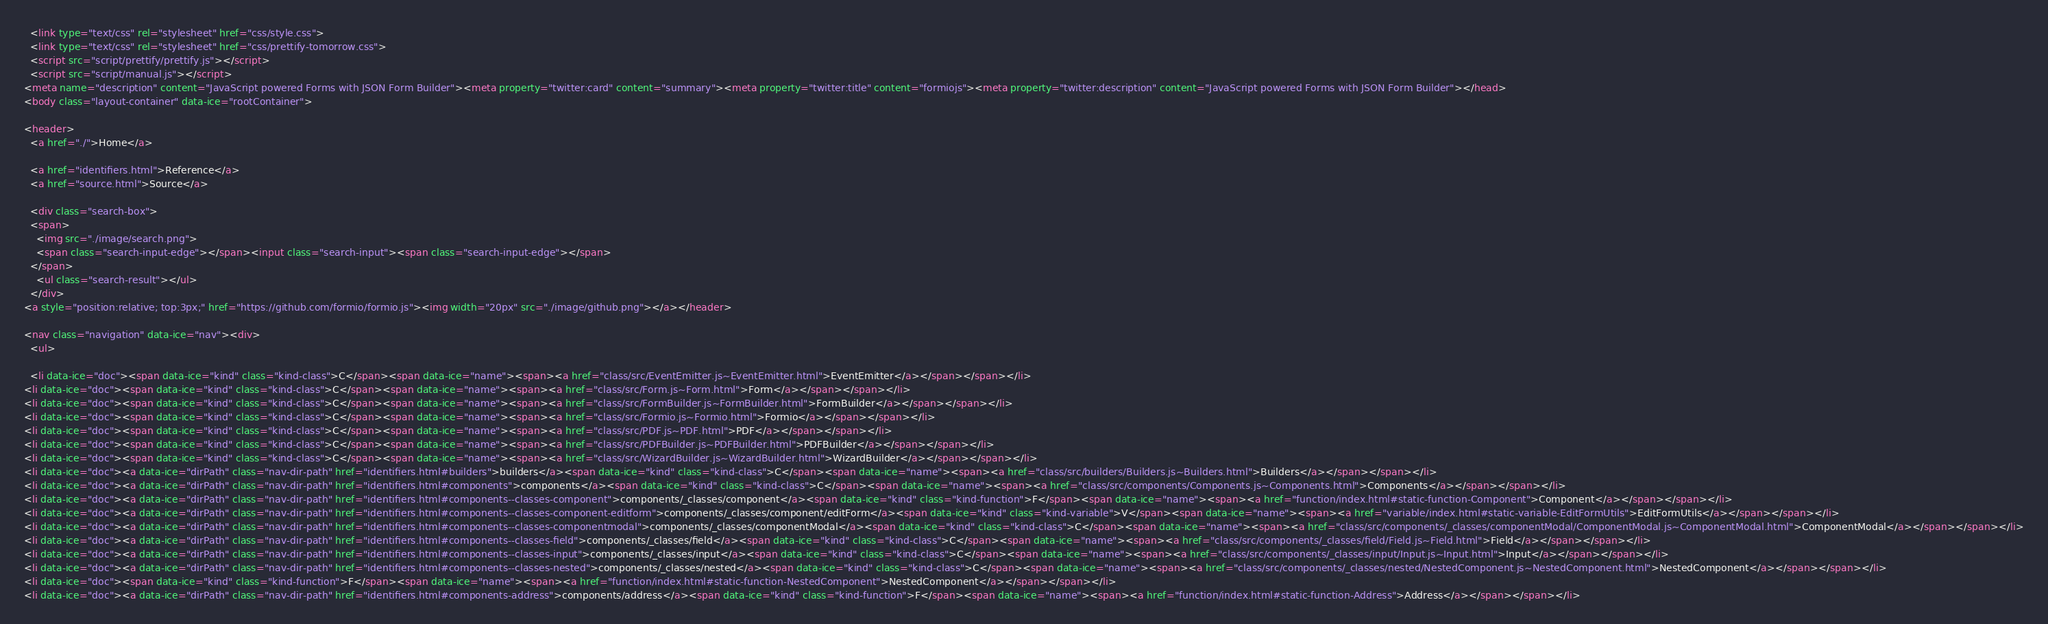<code> <loc_0><loc_0><loc_500><loc_500><_HTML_>  <link type="text/css" rel="stylesheet" href="css/style.css">
  <link type="text/css" rel="stylesheet" href="css/prettify-tomorrow.css">
  <script src="script/prettify/prettify.js"></script>
  <script src="script/manual.js"></script>
<meta name="description" content="JavaScript powered Forms with JSON Form Builder"><meta property="twitter:card" content="summary"><meta property="twitter:title" content="formiojs"><meta property="twitter:description" content="JavaScript powered Forms with JSON Form Builder"></head>
<body class="layout-container" data-ice="rootContainer">

<header>
  <a href="./">Home</a>
  
  <a href="identifiers.html">Reference</a>
  <a href="source.html">Source</a>
  
  <div class="search-box">
  <span>
    <img src="./image/search.png">
    <span class="search-input-edge"></span><input class="search-input"><span class="search-input-edge"></span>
  </span>
    <ul class="search-result"></ul>
  </div>
<a style="position:relative; top:3px;" href="https://github.com/formio/formio.js"><img width="20px" src="./image/github.png"></a></header>

<nav class="navigation" data-ice="nav"><div>
  <ul>
    
  <li data-ice="doc"><span data-ice="kind" class="kind-class">C</span><span data-ice="name"><span><a href="class/src/EventEmitter.js~EventEmitter.html">EventEmitter</a></span></span></li>
<li data-ice="doc"><span data-ice="kind" class="kind-class">C</span><span data-ice="name"><span><a href="class/src/Form.js~Form.html">Form</a></span></span></li>
<li data-ice="doc"><span data-ice="kind" class="kind-class">C</span><span data-ice="name"><span><a href="class/src/FormBuilder.js~FormBuilder.html">FormBuilder</a></span></span></li>
<li data-ice="doc"><span data-ice="kind" class="kind-class">C</span><span data-ice="name"><span><a href="class/src/Formio.js~Formio.html">Formio</a></span></span></li>
<li data-ice="doc"><span data-ice="kind" class="kind-class">C</span><span data-ice="name"><span><a href="class/src/PDF.js~PDF.html">PDF</a></span></span></li>
<li data-ice="doc"><span data-ice="kind" class="kind-class">C</span><span data-ice="name"><span><a href="class/src/PDFBuilder.js~PDFBuilder.html">PDFBuilder</a></span></span></li>
<li data-ice="doc"><span data-ice="kind" class="kind-class">C</span><span data-ice="name"><span><a href="class/src/WizardBuilder.js~WizardBuilder.html">WizardBuilder</a></span></span></li>
<li data-ice="doc"><a data-ice="dirPath" class="nav-dir-path" href="identifiers.html#builders">builders</a><span data-ice="kind" class="kind-class">C</span><span data-ice="name"><span><a href="class/src/builders/Builders.js~Builders.html">Builders</a></span></span></li>
<li data-ice="doc"><a data-ice="dirPath" class="nav-dir-path" href="identifiers.html#components">components</a><span data-ice="kind" class="kind-class">C</span><span data-ice="name"><span><a href="class/src/components/Components.js~Components.html">Components</a></span></span></li>
<li data-ice="doc"><a data-ice="dirPath" class="nav-dir-path" href="identifiers.html#components--classes-component">components/_classes/component</a><span data-ice="kind" class="kind-function">F</span><span data-ice="name"><span><a href="function/index.html#static-function-Component">Component</a></span></span></li>
<li data-ice="doc"><a data-ice="dirPath" class="nav-dir-path" href="identifiers.html#components--classes-component-editform">components/_classes/component/editForm</a><span data-ice="kind" class="kind-variable">V</span><span data-ice="name"><span><a href="variable/index.html#static-variable-EditFormUtils">EditFormUtils</a></span></span></li>
<li data-ice="doc"><a data-ice="dirPath" class="nav-dir-path" href="identifiers.html#components--classes-componentmodal">components/_classes/componentModal</a><span data-ice="kind" class="kind-class">C</span><span data-ice="name"><span><a href="class/src/components/_classes/componentModal/ComponentModal.js~ComponentModal.html">ComponentModal</a></span></span></li>
<li data-ice="doc"><a data-ice="dirPath" class="nav-dir-path" href="identifiers.html#components--classes-field">components/_classes/field</a><span data-ice="kind" class="kind-class">C</span><span data-ice="name"><span><a href="class/src/components/_classes/field/Field.js~Field.html">Field</a></span></span></li>
<li data-ice="doc"><a data-ice="dirPath" class="nav-dir-path" href="identifiers.html#components--classes-input">components/_classes/input</a><span data-ice="kind" class="kind-class">C</span><span data-ice="name"><span><a href="class/src/components/_classes/input/Input.js~Input.html">Input</a></span></span></li>
<li data-ice="doc"><a data-ice="dirPath" class="nav-dir-path" href="identifiers.html#components--classes-nested">components/_classes/nested</a><span data-ice="kind" class="kind-class">C</span><span data-ice="name"><span><a href="class/src/components/_classes/nested/NestedComponent.js~NestedComponent.html">NestedComponent</a></span></span></li>
<li data-ice="doc"><span data-ice="kind" class="kind-function">F</span><span data-ice="name"><span><a href="function/index.html#static-function-NestedComponent">NestedComponent</a></span></span></li>
<li data-ice="doc"><a data-ice="dirPath" class="nav-dir-path" href="identifiers.html#components-address">components/address</a><span data-ice="kind" class="kind-function">F</span><span data-ice="name"><span><a href="function/index.html#static-function-Address">Address</a></span></span></li></code> 